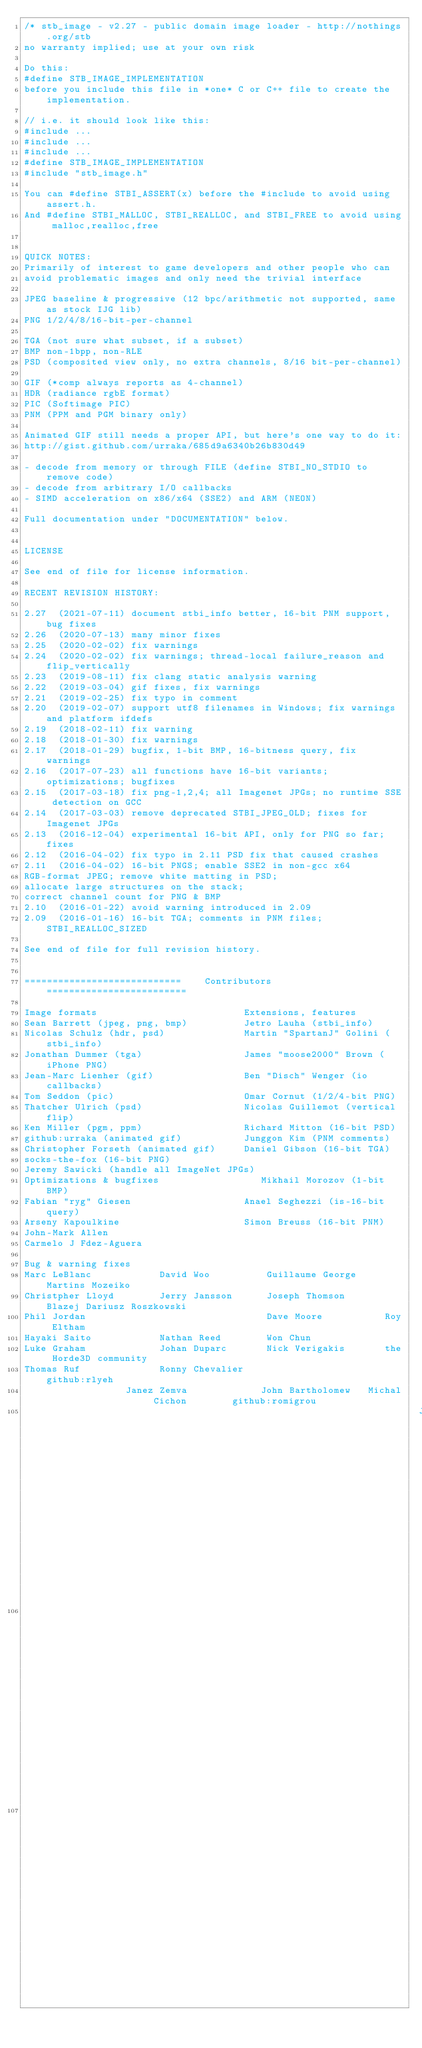Convert code to text. <code><loc_0><loc_0><loc_500><loc_500><_C_>/* stb_image - v2.27 - public domain image loader - http://nothings.org/stb
no warranty implied; use at your own risk

Do this:
#define STB_IMAGE_IMPLEMENTATION
before you include this file in *one* C or C++ file to create the implementation.

// i.e. it should look like this:
#include ...
#include ...
#include ...
#define STB_IMAGE_IMPLEMENTATION
#include "stb_image.h"

You can #define STBI_ASSERT(x) before the #include to avoid using assert.h.
And #define STBI_MALLOC, STBI_REALLOC, and STBI_FREE to avoid using malloc,realloc,free


QUICK NOTES:
Primarily of interest to game developers and other people who can
avoid problematic images and only need the trivial interface

JPEG baseline & progressive (12 bpc/arithmetic not supported, same as stock IJG lib)
PNG 1/2/4/8/16-bit-per-channel

TGA (not sure what subset, if a subset)
BMP non-1bpp, non-RLE
PSD (composited view only, no extra channels, 8/16 bit-per-channel)

GIF (*comp always reports as 4-channel)
HDR (radiance rgbE format)
PIC (Softimage PIC)
PNM (PPM and PGM binary only)

Animated GIF still needs a proper API, but here's one way to do it:
http://gist.github.com/urraka/685d9a6340b26b830d49

- decode from memory or through FILE (define STBI_NO_STDIO to remove code)
- decode from arbitrary I/O callbacks
- SIMD acceleration on x86/x64 (SSE2) and ARM (NEON)

Full documentation under "DOCUMENTATION" below.


LICENSE

See end of file for license information.

RECENT REVISION HISTORY:

2.27  (2021-07-11) document stbi_info better, 16-bit PNM support, bug fixes
2.26  (2020-07-13) many minor fixes
2.25  (2020-02-02) fix warnings
2.24  (2020-02-02) fix warnings; thread-local failure_reason and flip_vertically
2.23  (2019-08-11) fix clang static analysis warning
2.22  (2019-03-04) gif fixes, fix warnings
2.21  (2019-02-25) fix typo in comment
2.20  (2019-02-07) support utf8 filenames in Windows; fix warnings and platform ifdefs
2.19  (2018-02-11) fix warning
2.18  (2018-01-30) fix warnings
2.17  (2018-01-29) bugfix, 1-bit BMP, 16-bitness query, fix warnings
2.16  (2017-07-23) all functions have 16-bit variants; optimizations; bugfixes
2.15  (2017-03-18) fix png-1,2,4; all Imagenet JPGs; no runtime SSE detection on GCC
2.14  (2017-03-03) remove deprecated STBI_JPEG_OLD; fixes for Imagenet JPGs
2.13  (2016-12-04) experimental 16-bit API, only for PNG so far; fixes
2.12  (2016-04-02) fix typo in 2.11 PSD fix that caused crashes
2.11  (2016-04-02) 16-bit PNGS; enable SSE2 in non-gcc x64
RGB-format JPEG; remove white matting in PSD;
allocate large structures on the stack;
correct channel count for PNG & BMP
2.10  (2016-01-22) avoid warning introduced in 2.09
2.09  (2016-01-16) 16-bit TGA; comments in PNM files; STBI_REALLOC_SIZED

See end of file for full revision history.


============================    Contributors    =========================

Image formats                          Extensions, features
Sean Barrett (jpeg, png, bmp)          Jetro Lauha (stbi_info)
Nicolas Schulz (hdr, psd)              Martin "SpartanJ" Golini (stbi_info)
Jonathan Dummer (tga)                  James "moose2000" Brown (iPhone PNG)
Jean-Marc Lienher (gif)                Ben "Disch" Wenger (io callbacks)
Tom Seddon (pic)                       Omar Cornut (1/2/4-bit PNG)
Thatcher Ulrich (psd)                  Nicolas Guillemot (vertical flip)
Ken Miller (pgm, ppm)                  Richard Mitton (16-bit PSD)
github:urraka (animated gif)           Junggon Kim (PNM comments)
Christopher Forseth (animated gif)     Daniel Gibson (16-bit TGA)
socks-the-fox (16-bit PNG)
Jeremy Sawicki (handle all ImageNet JPGs)
Optimizations & bugfixes                  Mikhail Morozov (1-bit BMP)
Fabian "ryg" Giesen                    Anael Seghezzi (is-16-bit query)
Arseny Kapoulkine                      Simon Breuss (16-bit PNM)
John-Mark Allen
Carmelo J Fdez-Aguera

Bug & warning fixes
Marc LeBlanc            David Woo          Guillaume George     Martins Mozeiko
Christpher Lloyd        Jerry Jansson      Joseph Thomson       Blazej Dariusz Roszkowski
Phil Jordan                                Dave Moore           Roy Eltham
Hayaki Saito            Nathan Reed        Won Chun
Luke Graham             Johan Duparc       Nick Verigakis       the Horde3D community
Thomas Ruf              Ronny Chevalier                         github:rlyeh
                  Janez Zemva             John Bartholomew   Michal Cichon        github:romigrou
                                                                      Jonathan Blow           Ken Hamada         Tero Hanninen        github:svdijk
                                                                                                                      Eugene Golushkov        Laurent Gomila     Cort Stratton        github:snagar
                                                                                                                                                                             Aruelien Pocheville     Sergio Gonzalez    Thibault Reuille     github:Zelex</code> 